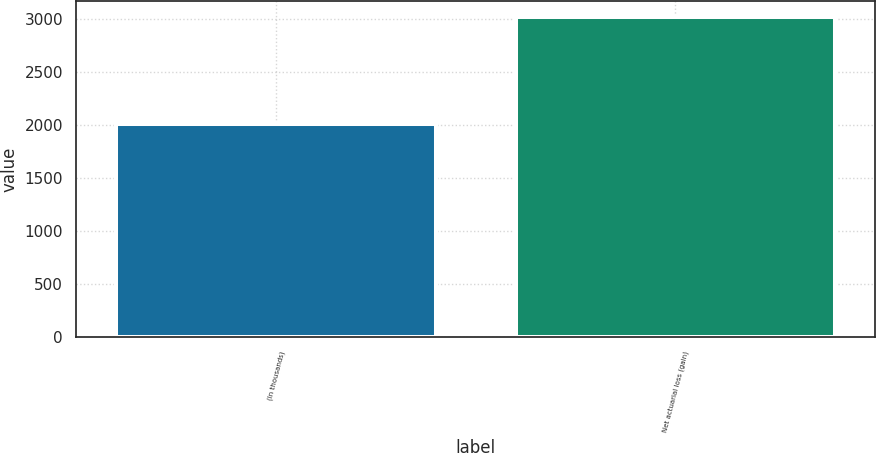<chart> <loc_0><loc_0><loc_500><loc_500><bar_chart><fcel>(In thousands)<fcel>Net actuarial loss (gain)<nl><fcel>2011<fcel>3020<nl></chart> 